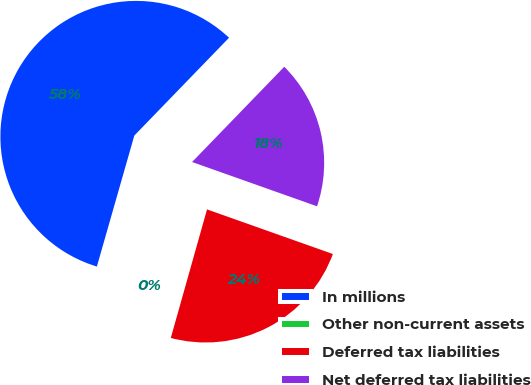Convert chart. <chart><loc_0><loc_0><loc_500><loc_500><pie_chart><fcel>In millions<fcel>Other non-current assets<fcel>Deferred tax liabilities<fcel>Net deferred tax liabilities<nl><fcel>57.81%<fcel>0.06%<fcel>23.95%<fcel>18.18%<nl></chart> 